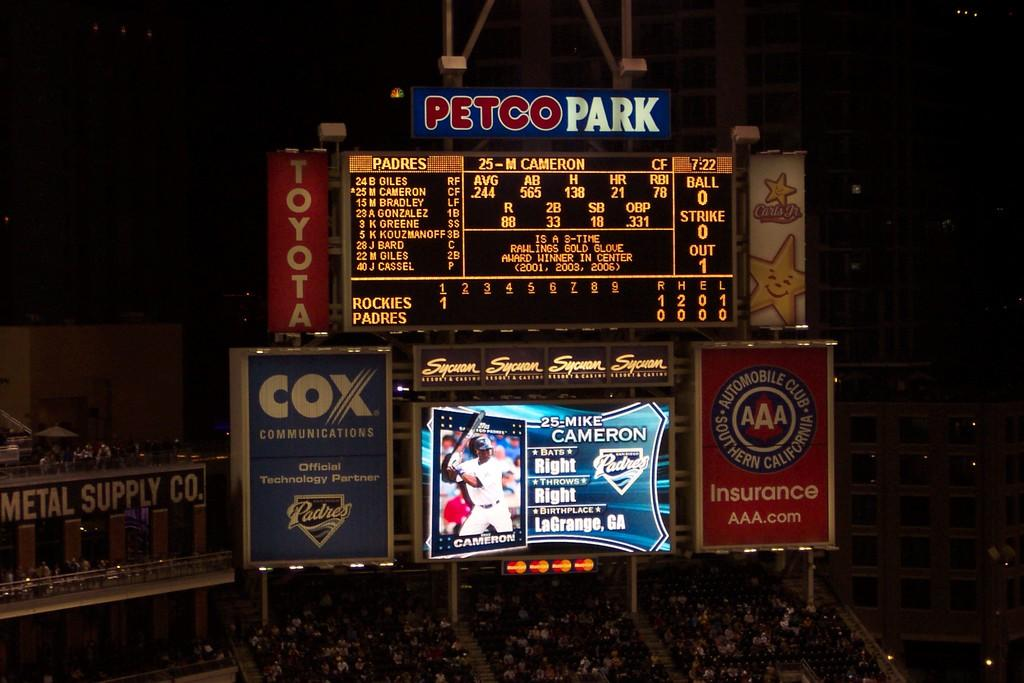<image>
Provide a brief description of the given image. A bunch of signs on a billboard that says PETCOPARK. 